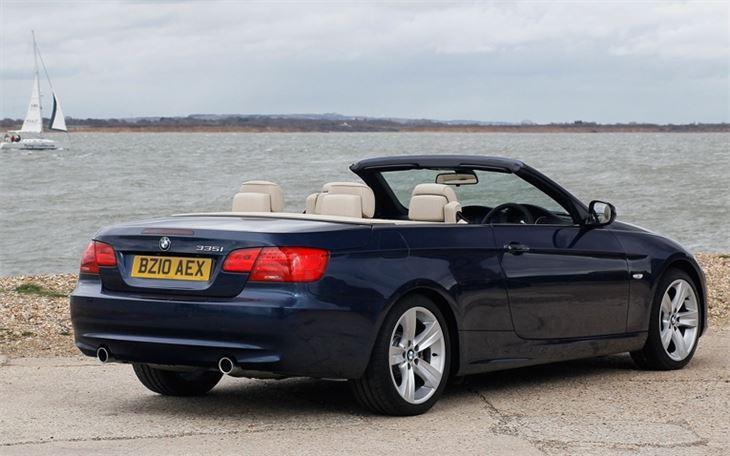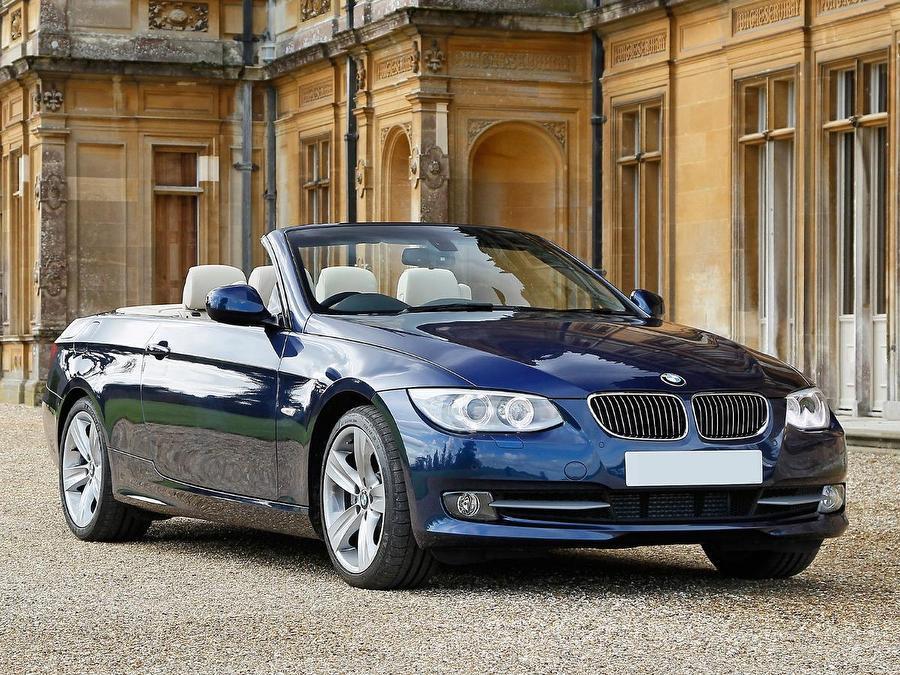The first image is the image on the left, the second image is the image on the right. For the images shown, is this caption "An image shows a forward-facing royal blue convertible with some type of wall behind it." true? Answer yes or no. Yes. The first image is the image on the left, the second image is the image on the right. Given the left and right images, does the statement "AN image contains a blue convertible sports car." hold true? Answer yes or no. Yes. 